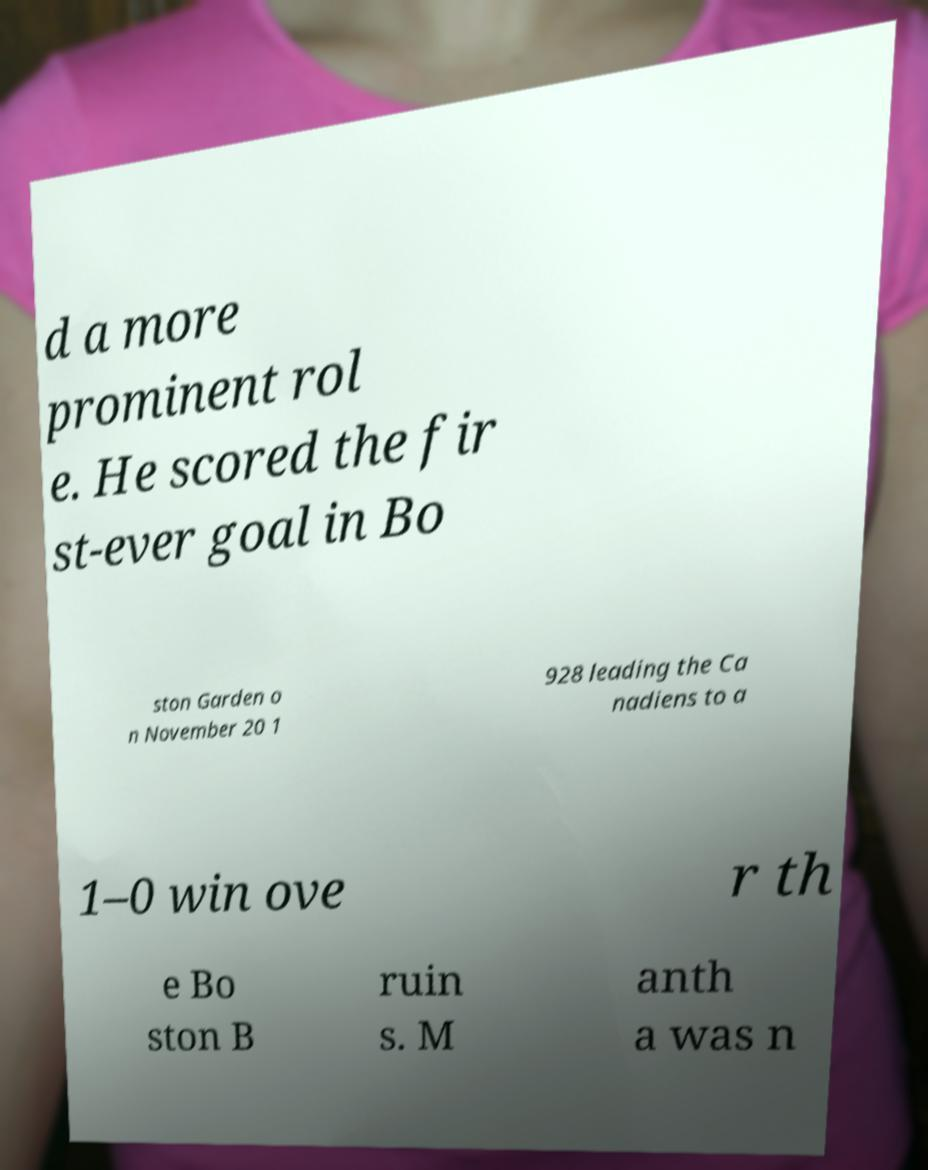I need the written content from this picture converted into text. Can you do that? d a more prominent rol e. He scored the fir st-ever goal in Bo ston Garden o n November 20 1 928 leading the Ca nadiens to a 1–0 win ove r th e Bo ston B ruin s. M anth a was n 